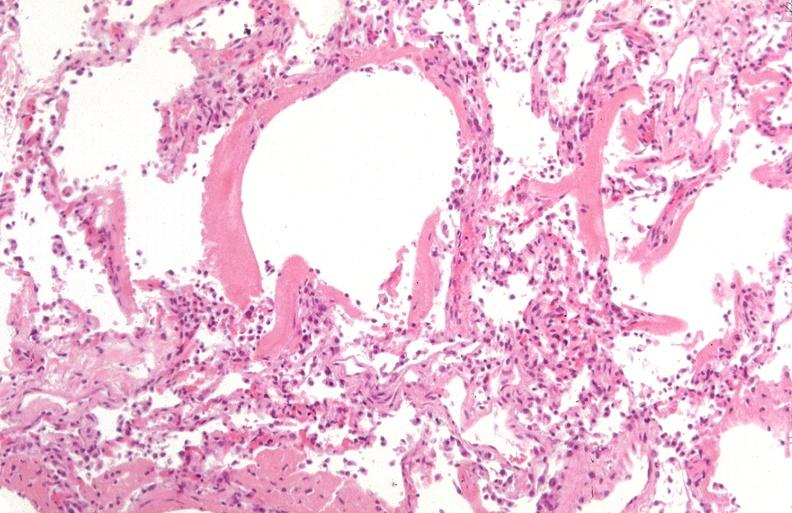what does this image show?
Answer the question using a single word or phrase. Lung 